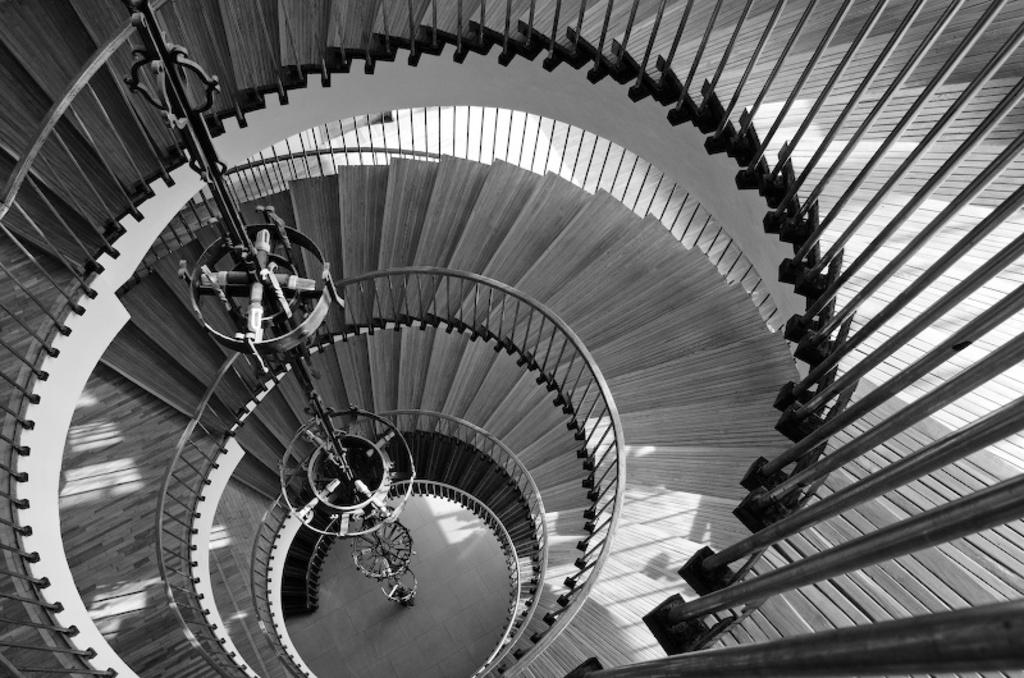What is the color scheme of the image? The image is black and white. What structure can be seen in the image? There is a staircase in the image. How are the steps of the staircase arranged? The steps of the staircase form a round shape from the bottom. Can you see any cracks in the staircase in the image? There is no mention of cracks in the image, so we cannot determine if any are present. Is there a needle being used on the staircase in the image? There is no needle present in the image. 